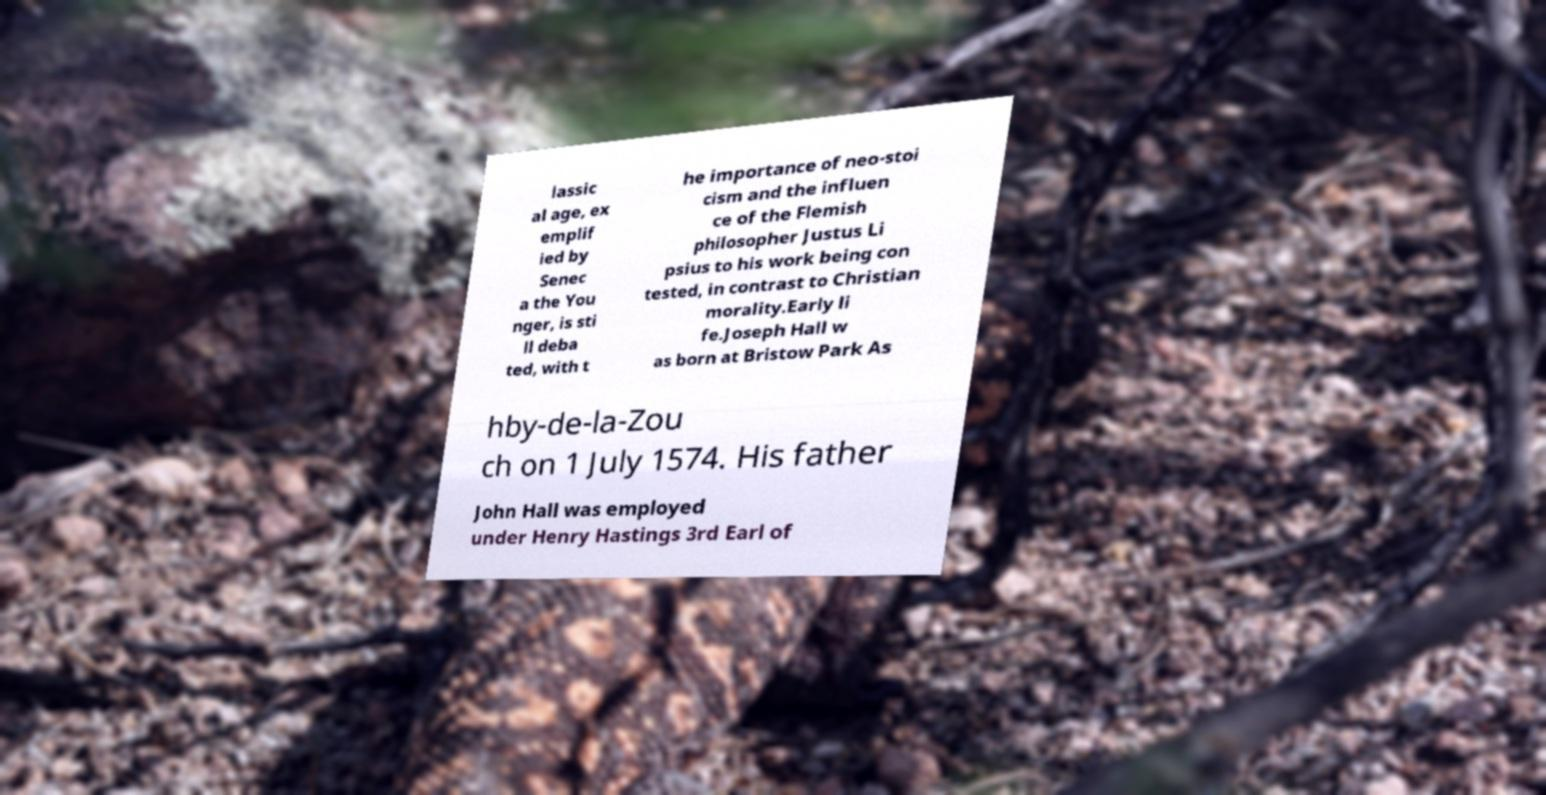Could you assist in decoding the text presented in this image and type it out clearly? lassic al age, ex emplif ied by Senec a the You nger, is sti ll deba ted, with t he importance of neo-stoi cism and the influen ce of the Flemish philosopher Justus Li psius to his work being con tested, in contrast to Christian morality.Early li fe.Joseph Hall w as born at Bristow Park As hby-de-la-Zou ch on 1 July 1574. His father John Hall was employed under Henry Hastings 3rd Earl of 